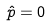Convert formula to latex. <formula><loc_0><loc_0><loc_500><loc_500>\hat { p } = 0</formula> 